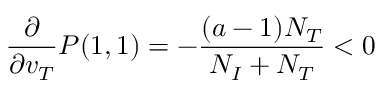Convert formula to latex. <formula><loc_0><loc_0><loc_500><loc_500>\frac { \partial } { \partial v _ { T } } P ( 1 , 1 ) = - \frac { ( a - 1 ) N _ { T } } { N _ { I } + N _ { T } } < 0</formula> 